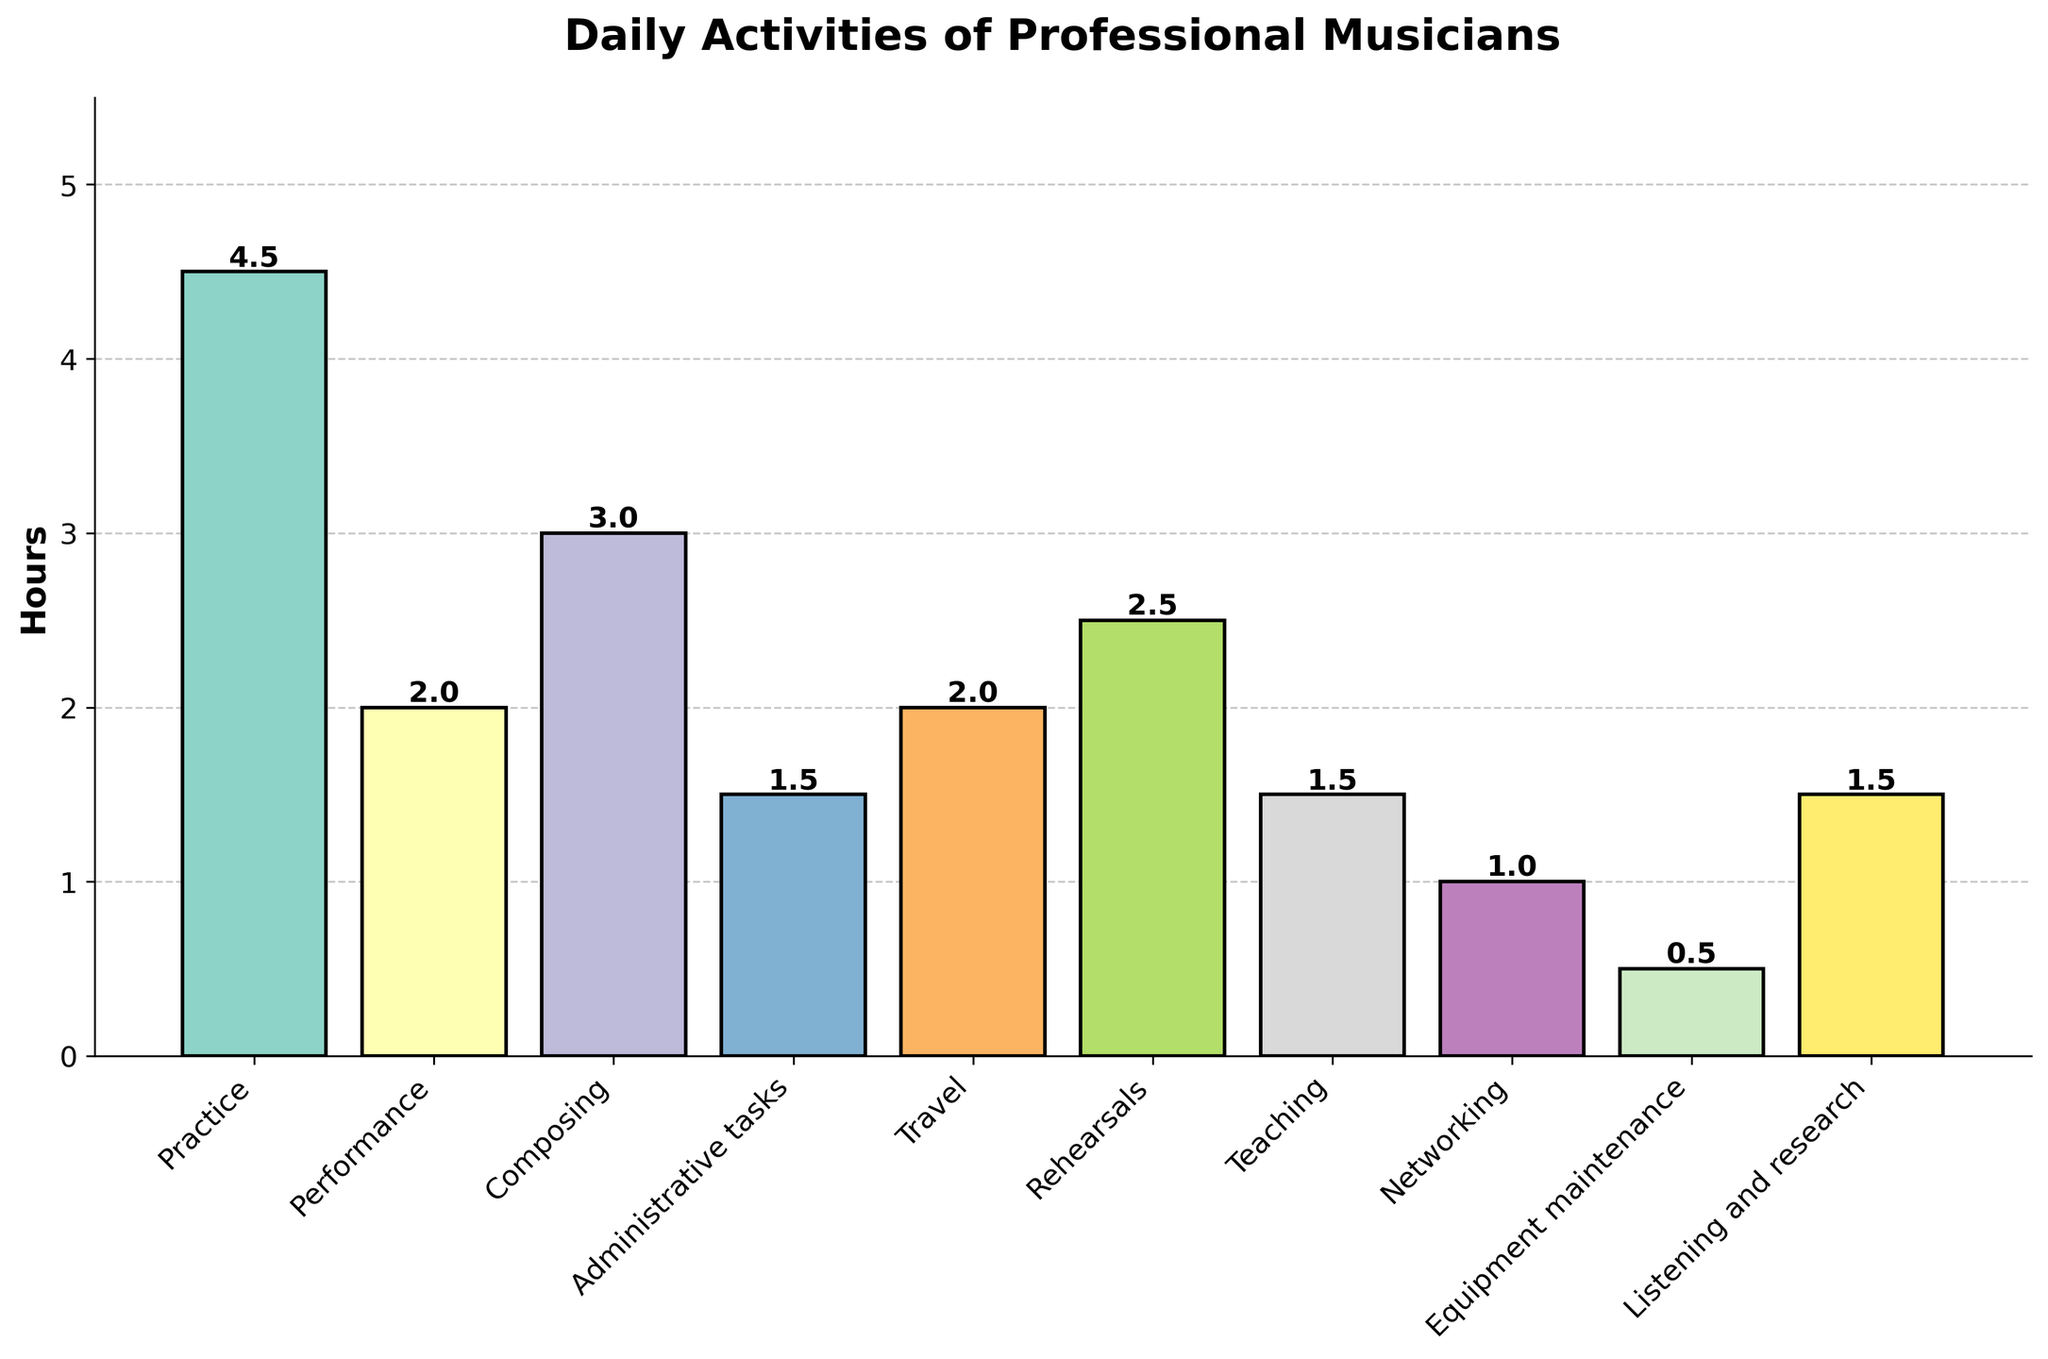How many more hours do musicians spend practicing than performing? To find the difference, look at the bars for "Practice" and "Performance". The "Practice" bar is at 4.5 hours and the "Performance" bar is at 2 hours. Subtract the two values: 4.5 - 2 = 2.5.
Answer: 2.5 hours Which activity do musicians spend the most time on? To determine the activity with the highest time spent, look for the tallest bar. The bar for "Practice" is the tallest at 4.5 hours.
Answer: Practice Is the time spent on composing more or less than time spent on rehearsals? Compare the heights of the bars for "Composing" and "Rehearsals". The "Composing" bar is at 3 hours and the "Rehearsals" bar is at 2.5 hours. 3 is greater than 2.5.
Answer: More What is the total time spent on teaching and networking? Add the hours for "Teaching" and "Networking". The bar for teaching is at 1.5 hours and the bar for networking is at 1 hour. So, 1.5 + 1 = 2.5.
Answer: 2.5 hours Which activities take up exactly 1.5 hours? Identify the bars that reach exactly 1.5 hours. The bars for "Administrative tasks", "Teaching", and "Listening and research" each reach 1.5 hours.
Answer: Administrative tasks, Teaching, Listening and research What is the difference in hours between the activity with the highest and lowest time spent? First, identify the highest (Practice at 4.5 hours) and the lowest (Equipment maintenance at 0.5 hours). Then subtract the lowest from the highest: 4.5 - 0.5 = 4.
Answer: 4 hours Do musicians spend more time on traveling or equipment maintenance? Compare the heights of the bars for "Travel" and "Equipment maintenance". The "Travel" bar is at 2 hours, while the "Equipment maintenance" bar is at 0.5 hours.
Answer: Traveling What is the average time spent on practice, performance, and composing combined? Add the time spent on each of the three activities and divide by the number of activities. (4.5 + 2 + 3) / 3 = 9.5 / 3 = 3.17.
Answer: 3.17 hours How much more time do musicians spend practicing than on administrative tasks? Look at the bars for "Practice" and "Administrative tasks". The "Practice" bar is at 4.5 hours and the "Administrative tasks" bar is at 1.5 hours. Subtract 1.5 from 4.5 to get 3.
Answer: 3 hours Which activities do musicians spend exactly the same amount of time on, and what is that time? Identify bars with exactly the same height. "Administrative tasks", "Teaching", and "Listening and research" all have bars reaching 1.5 hours.
Answer: 1.5 hours 